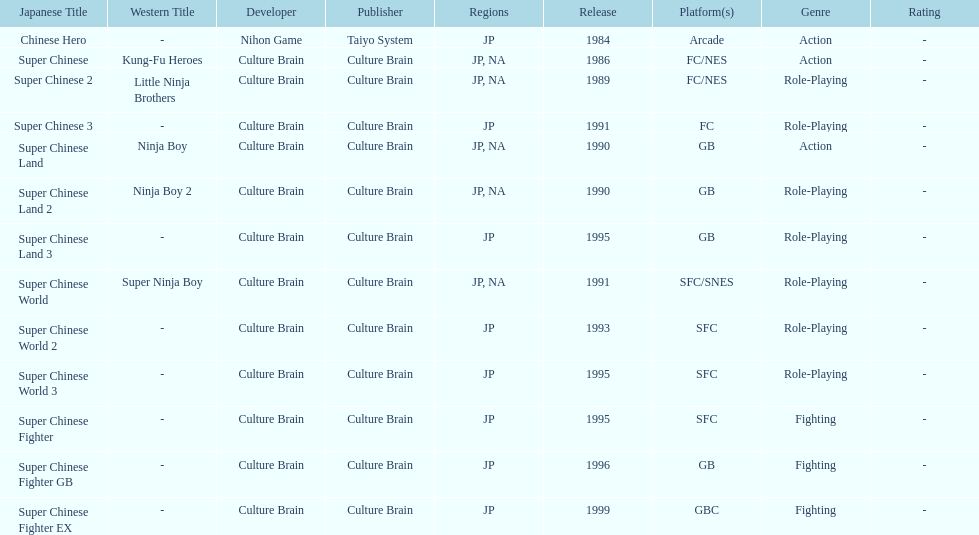Which platforms had the most titles released? GB. 